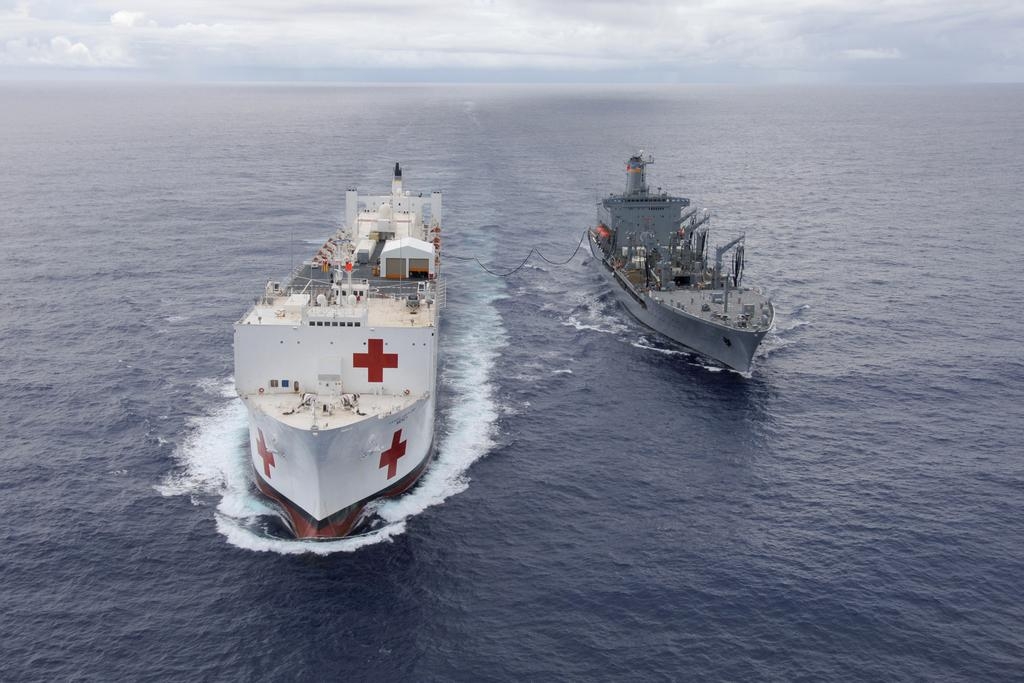Where was the image taken? The image is clicked outside the city. What can be seen in the water in the image? There are two ships in the water. How are the ships moving in the image? The ships are running on the water body. What is visible in the background of the image? There is a sky visible in the background. What type of polish is being applied to the mountain in the image? There is no mountain or polish present in the image. What scientific theory can be observed in action in the image? There is no scientific theory observable in the image; it features two ships in the water and a sky in the background. 